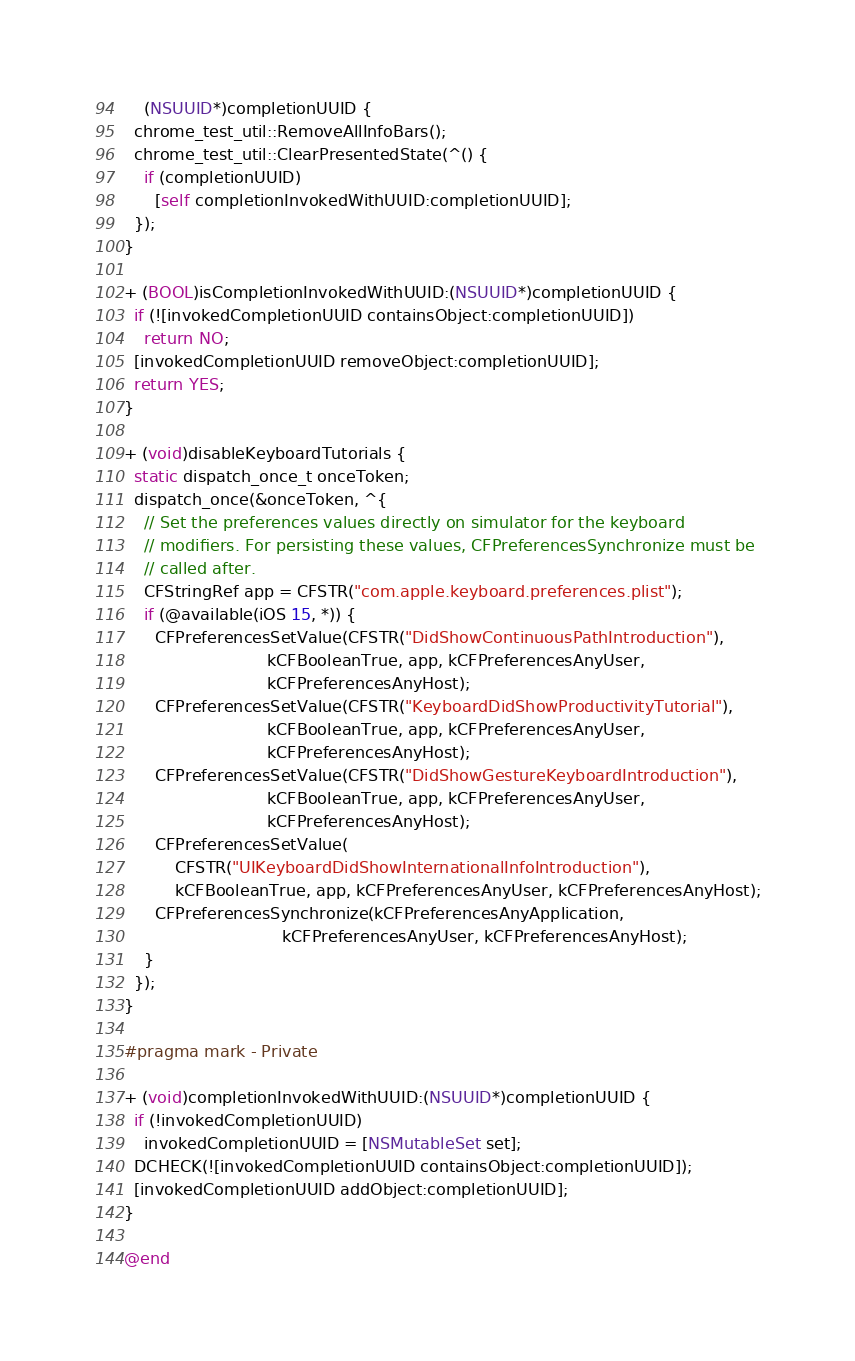Convert code to text. <code><loc_0><loc_0><loc_500><loc_500><_ObjectiveC_>    (NSUUID*)completionUUID {
  chrome_test_util::RemoveAllInfoBars();
  chrome_test_util::ClearPresentedState(^() {
    if (completionUUID)
      [self completionInvokedWithUUID:completionUUID];
  });
}

+ (BOOL)isCompletionInvokedWithUUID:(NSUUID*)completionUUID {
  if (![invokedCompletionUUID containsObject:completionUUID])
    return NO;
  [invokedCompletionUUID removeObject:completionUUID];
  return YES;
}

+ (void)disableKeyboardTutorials {
  static dispatch_once_t onceToken;
  dispatch_once(&onceToken, ^{
    // Set the preferences values directly on simulator for the keyboard
    // modifiers. For persisting these values, CFPreferencesSynchronize must be
    // called after.
    CFStringRef app = CFSTR("com.apple.keyboard.preferences.plist");
    if (@available(iOS 15, *)) {
      CFPreferencesSetValue(CFSTR("DidShowContinuousPathIntroduction"),
                            kCFBooleanTrue, app, kCFPreferencesAnyUser,
                            kCFPreferencesAnyHost);
      CFPreferencesSetValue(CFSTR("KeyboardDidShowProductivityTutorial"),
                            kCFBooleanTrue, app, kCFPreferencesAnyUser,
                            kCFPreferencesAnyHost);
      CFPreferencesSetValue(CFSTR("DidShowGestureKeyboardIntroduction"),
                            kCFBooleanTrue, app, kCFPreferencesAnyUser,
                            kCFPreferencesAnyHost);
      CFPreferencesSetValue(
          CFSTR("UIKeyboardDidShowInternationalInfoIntroduction"),
          kCFBooleanTrue, app, kCFPreferencesAnyUser, kCFPreferencesAnyHost);
      CFPreferencesSynchronize(kCFPreferencesAnyApplication,
                               kCFPreferencesAnyUser, kCFPreferencesAnyHost);
    }
  });
}

#pragma mark - Private

+ (void)completionInvokedWithUUID:(NSUUID*)completionUUID {
  if (!invokedCompletionUUID)
    invokedCompletionUUID = [NSMutableSet set];
  DCHECK(![invokedCompletionUUID containsObject:completionUUID]);
  [invokedCompletionUUID addObject:completionUUID];
}

@end
</code> 